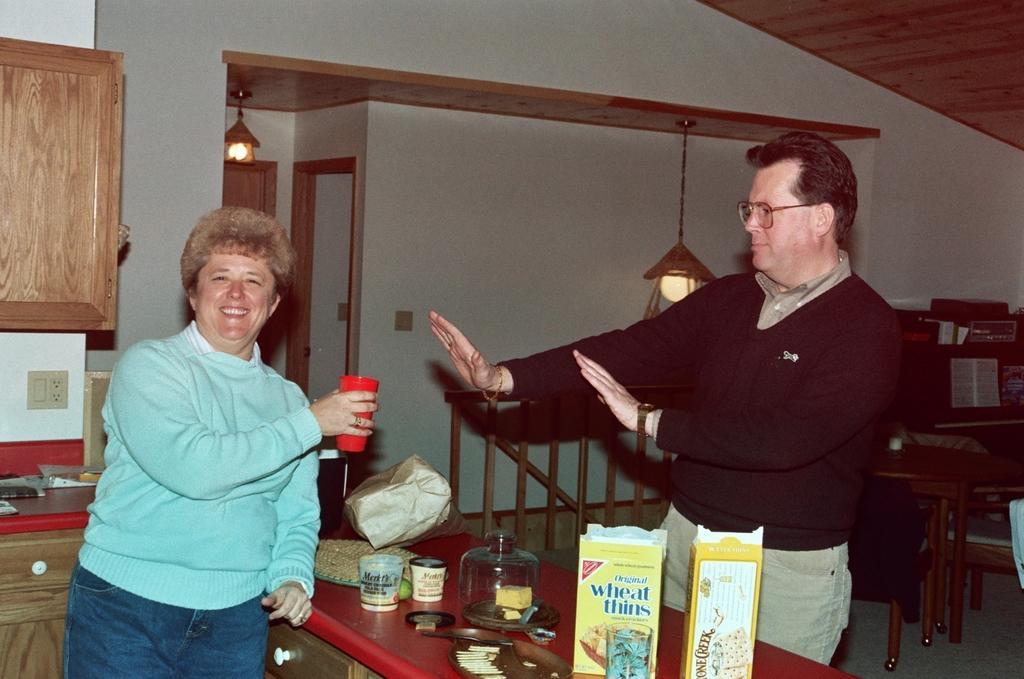Describe this image in one or two sentences. In this image, we can see two people are standing. Here a person is holding a glass, seeing and smiling. Here we can see few things, cupboards. Background we can see walls, door, lights, few things, railing, table and chair. 